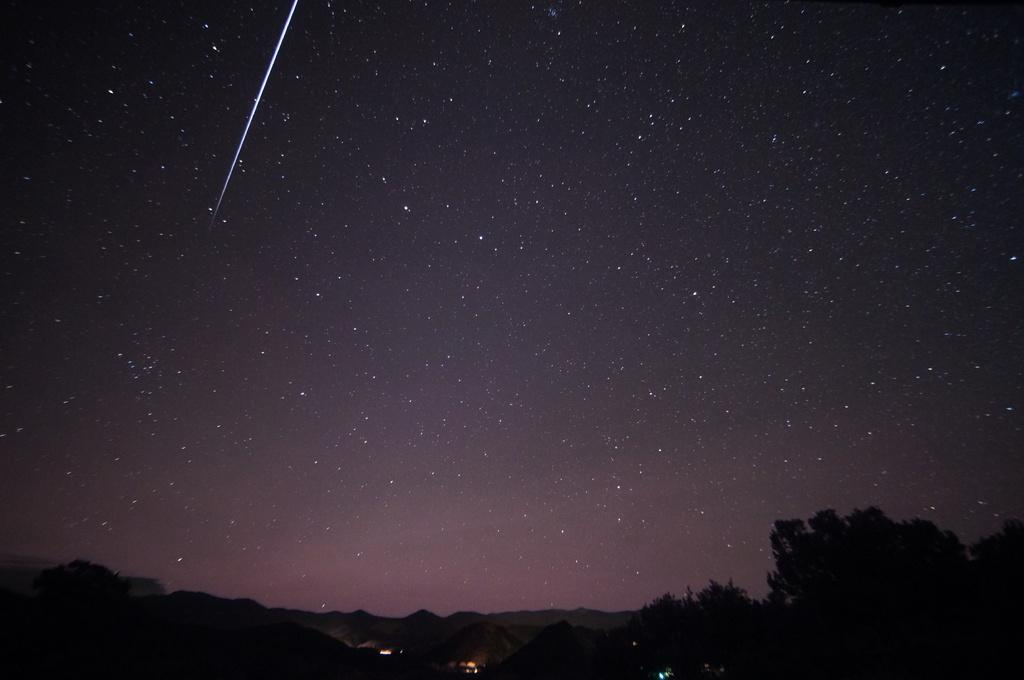What is the color or lighting condition at the bottom of the image? The bottom of the image is dark. What type of natural elements can be seen in the image? There are trees in the image. What type of structures are present in the image? There are huts in the image. What artificial light sources are visible in the image? There are lights visible in the image. What celestial objects can be seen in the sky in the image? Stars are present in the sky in the image. Can you see a turkey wearing underwear in the image? No, there is no turkey or underwear present in the image. 